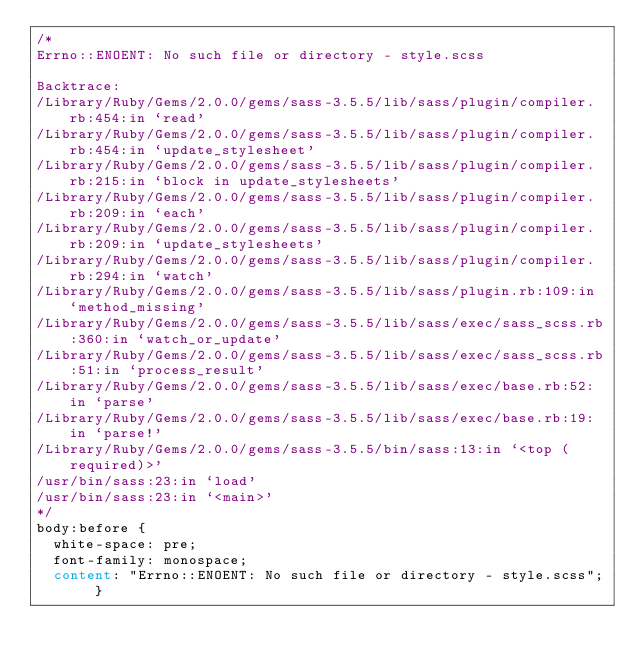Convert code to text. <code><loc_0><loc_0><loc_500><loc_500><_CSS_>/*
Errno::ENOENT: No such file or directory - style.scss

Backtrace:
/Library/Ruby/Gems/2.0.0/gems/sass-3.5.5/lib/sass/plugin/compiler.rb:454:in `read'
/Library/Ruby/Gems/2.0.0/gems/sass-3.5.5/lib/sass/plugin/compiler.rb:454:in `update_stylesheet'
/Library/Ruby/Gems/2.0.0/gems/sass-3.5.5/lib/sass/plugin/compiler.rb:215:in `block in update_stylesheets'
/Library/Ruby/Gems/2.0.0/gems/sass-3.5.5/lib/sass/plugin/compiler.rb:209:in `each'
/Library/Ruby/Gems/2.0.0/gems/sass-3.5.5/lib/sass/plugin/compiler.rb:209:in `update_stylesheets'
/Library/Ruby/Gems/2.0.0/gems/sass-3.5.5/lib/sass/plugin/compiler.rb:294:in `watch'
/Library/Ruby/Gems/2.0.0/gems/sass-3.5.5/lib/sass/plugin.rb:109:in `method_missing'
/Library/Ruby/Gems/2.0.0/gems/sass-3.5.5/lib/sass/exec/sass_scss.rb:360:in `watch_or_update'
/Library/Ruby/Gems/2.0.0/gems/sass-3.5.5/lib/sass/exec/sass_scss.rb:51:in `process_result'
/Library/Ruby/Gems/2.0.0/gems/sass-3.5.5/lib/sass/exec/base.rb:52:in `parse'
/Library/Ruby/Gems/2.0.0/gems/sass-3.5.5/lib/sass/exec/base.rb:19:in `parse!'
/Library/Ruby/Gems/2.0.0/gems/sass-3.5.5/bin/sass:13:in `<top (required)>'
/usr/bin/sass:23:in `load'
/usr/bin/sass:23:in `<main>'
*/
body:before {
  white-space: pre;
  font-family: monospace;
  content: "Errno::ENOENT: No such file or directory - style.scss"; }
</code> 